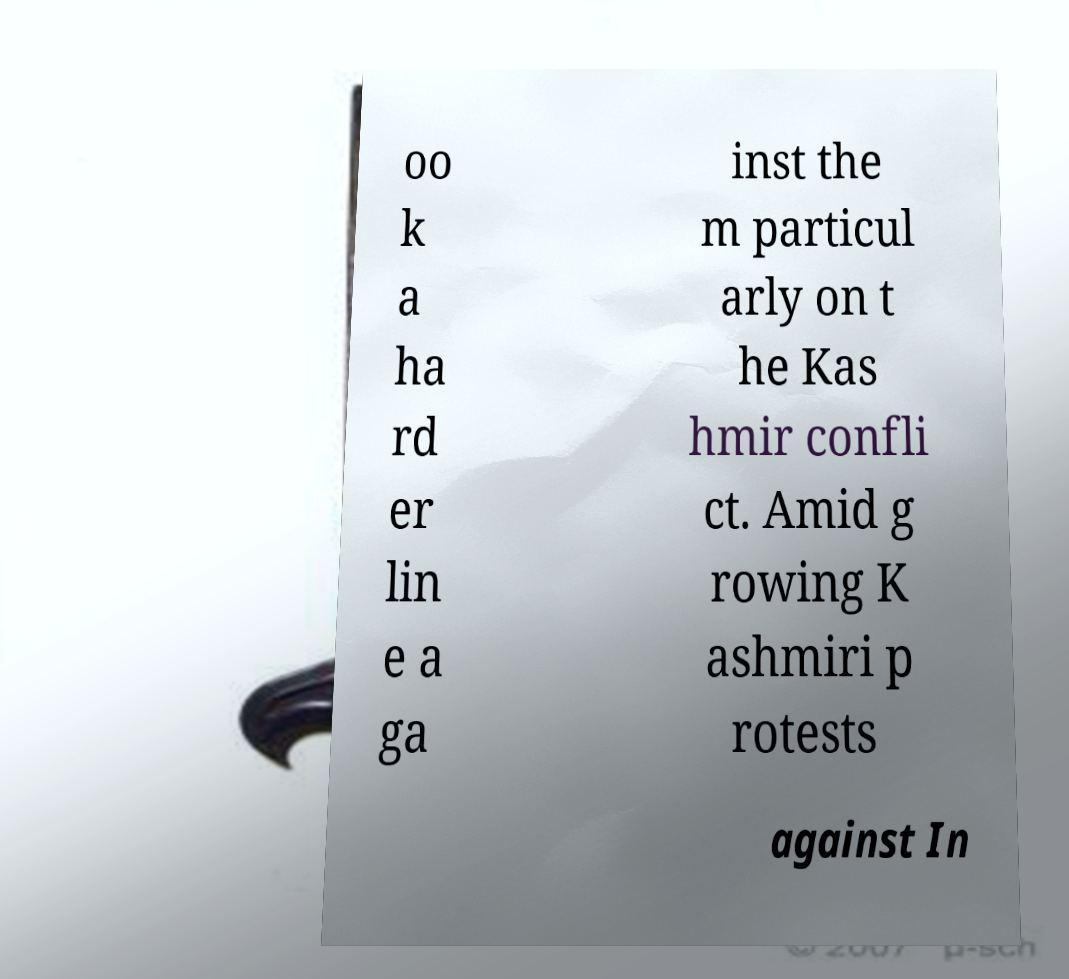Please identify and transcribe the text found in this image. oo k a ha rd er lin e a ga inst the m particul arly on t he Kas hmir confli ct. Amid g rowing K ashmiri p rotests against In 